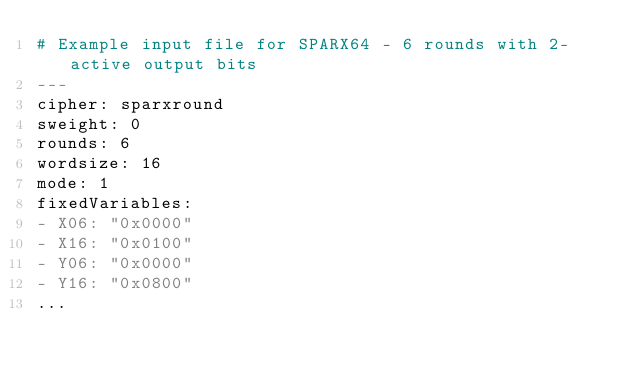<code> <loc_0><loc_0><loc_500><loc_500><_YAML_># Example input file for SPARX64 - 6 rounds with 2-active output bits
---
cipher: sparxround
sweight: 0
rounds: 6
wordsize: 16
mode: 1
fixedVariables:
- X06: "0x0000"
- X16: "0x0100"
- Y06: "0x0000"
- Y16: "0x0800"
...

</code> 